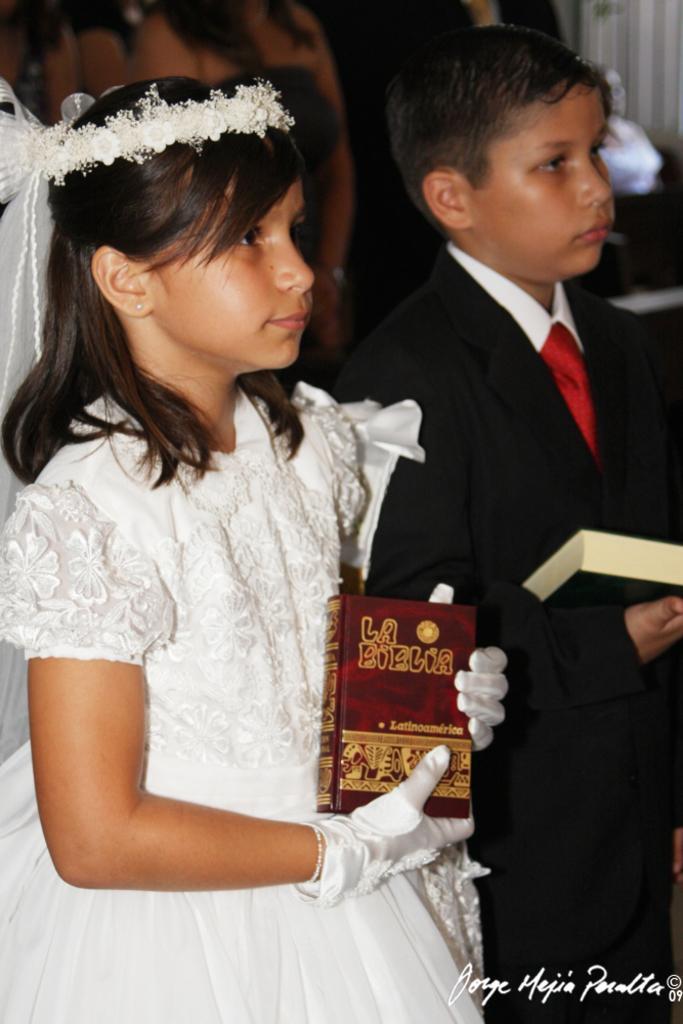Describe this image in one or two sentences. In this picture we can observe two children. We can observe a girl wearing white color dress and holding a book in her hands. There is a boy wearing a coat and holding a book in his hands. We can observe white color text on the right side. The background is completely blurred. 